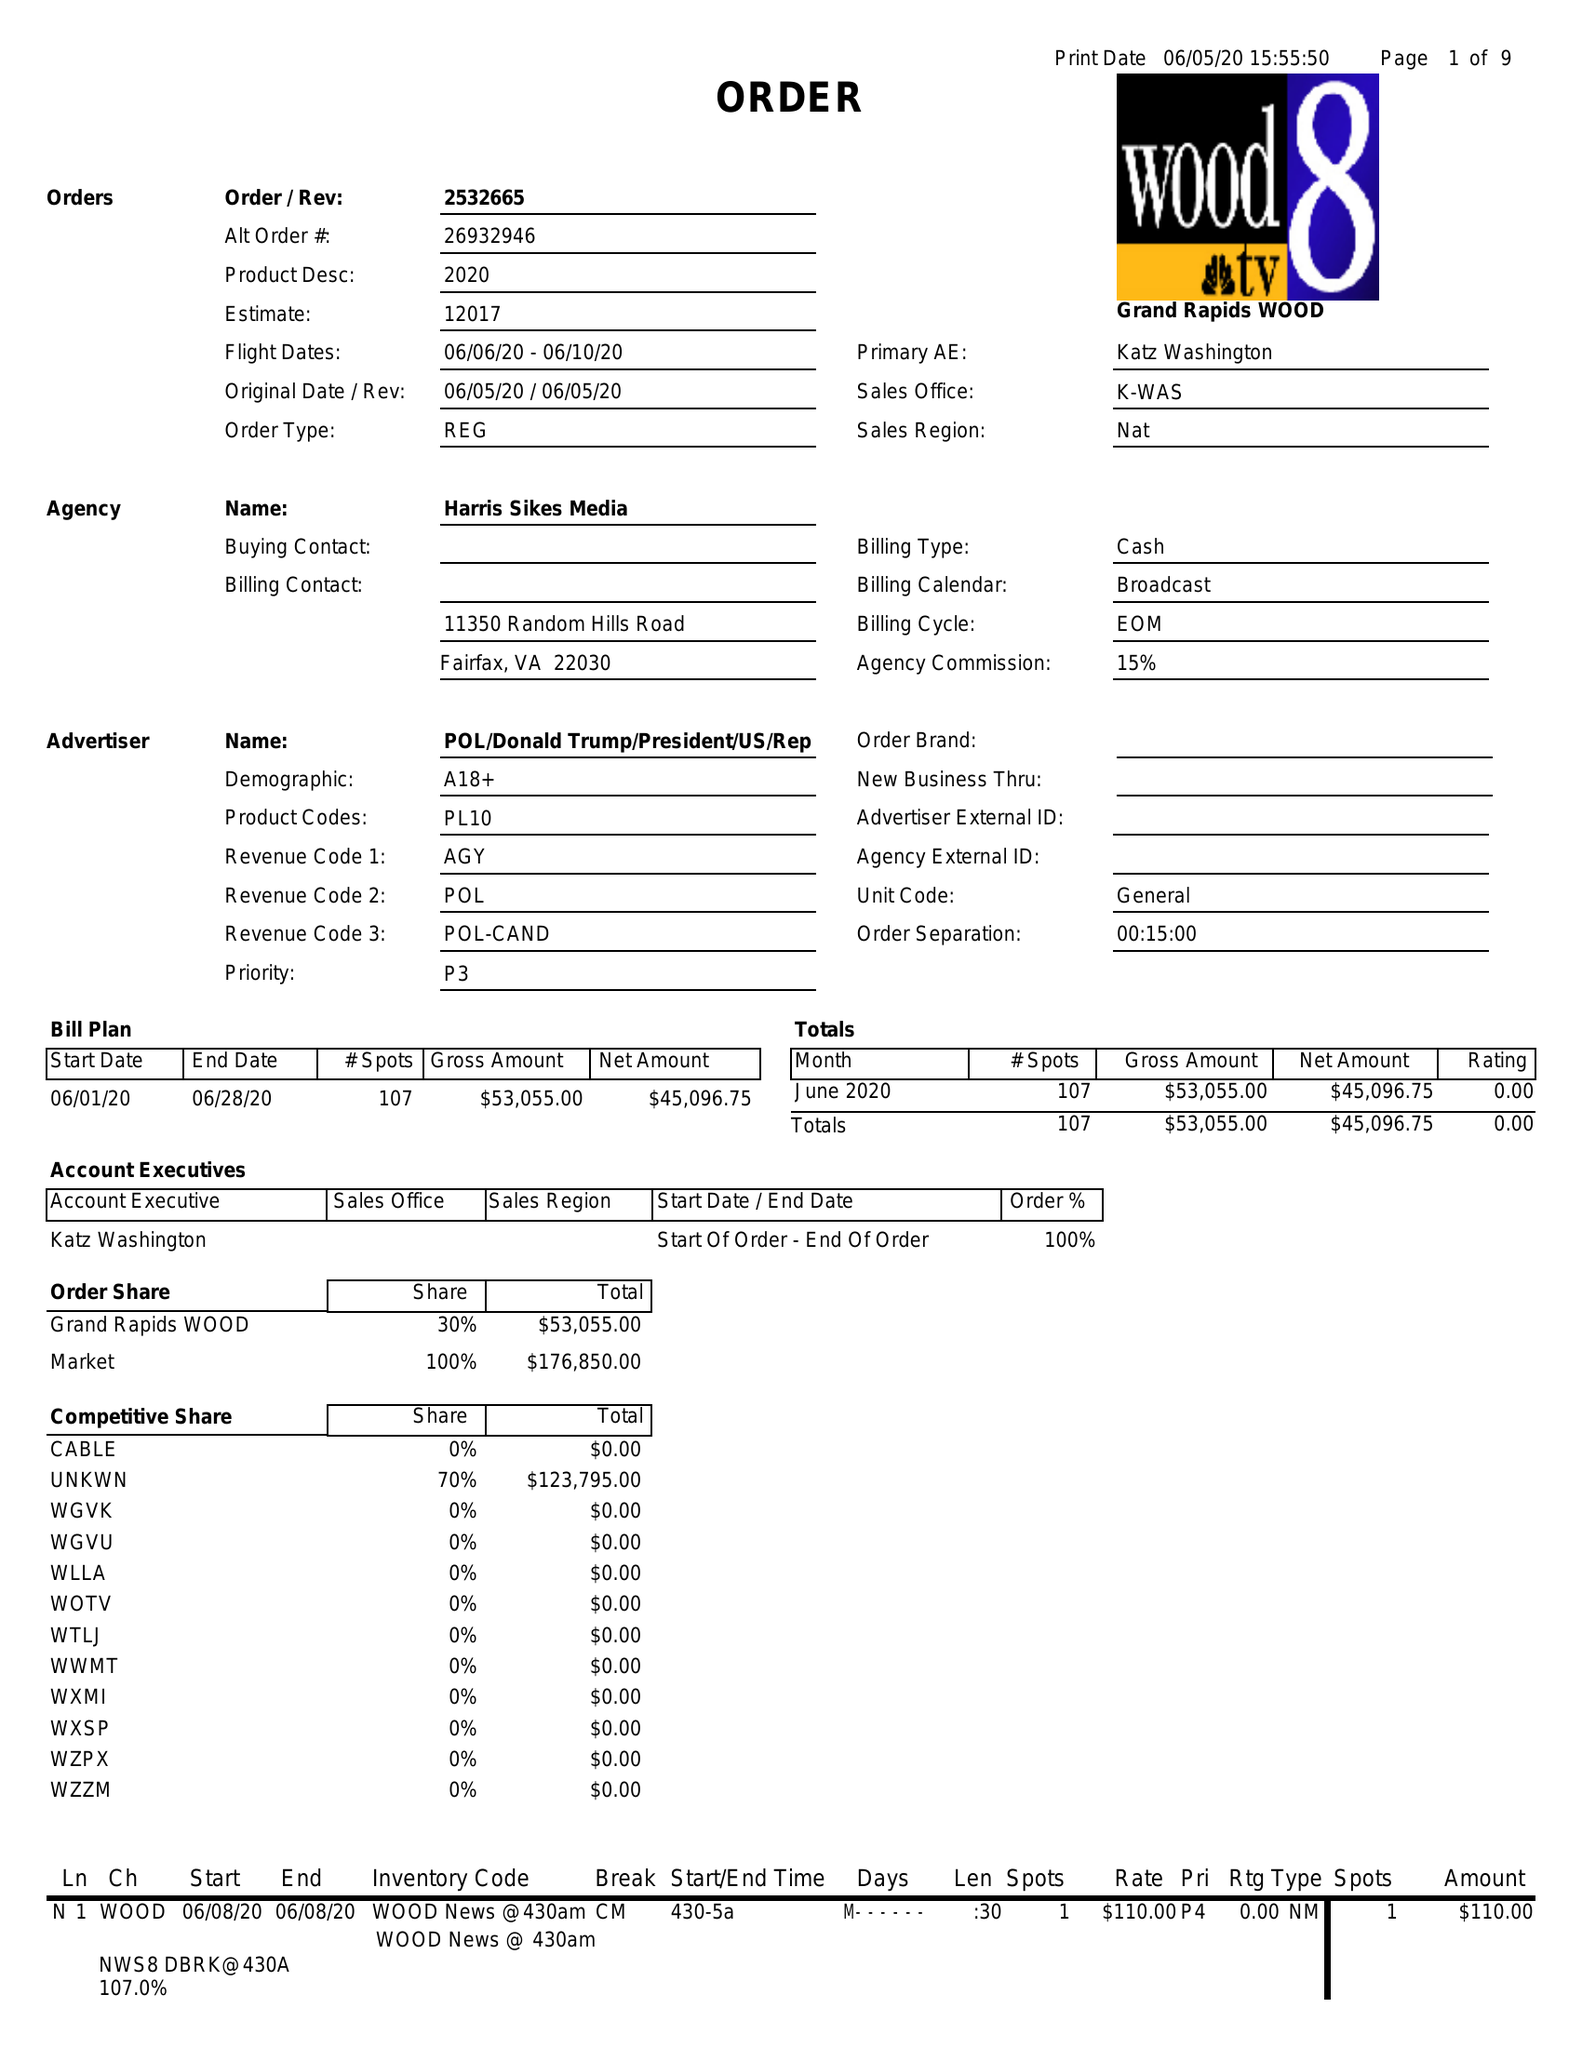What is the value for the gross_amount?
Answer the question using a single word or phrase. 53055.00 